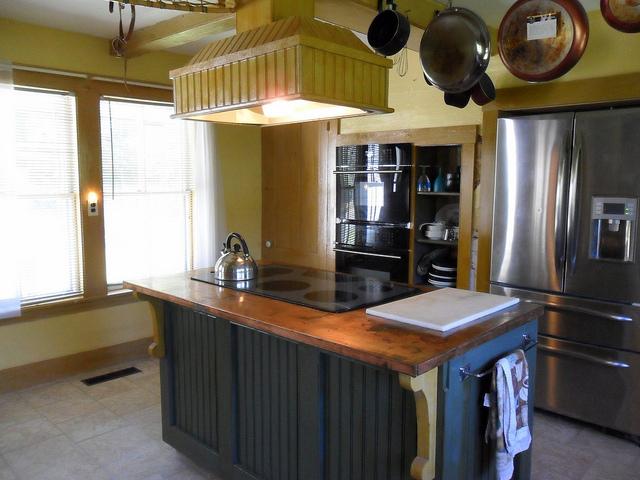What is on the stove top?
Be succinct. Tea kettle. What room is this?
Quick response, please. Kitchen. Are there towels hanging in this picture?
Write a very short answer. Yes. 